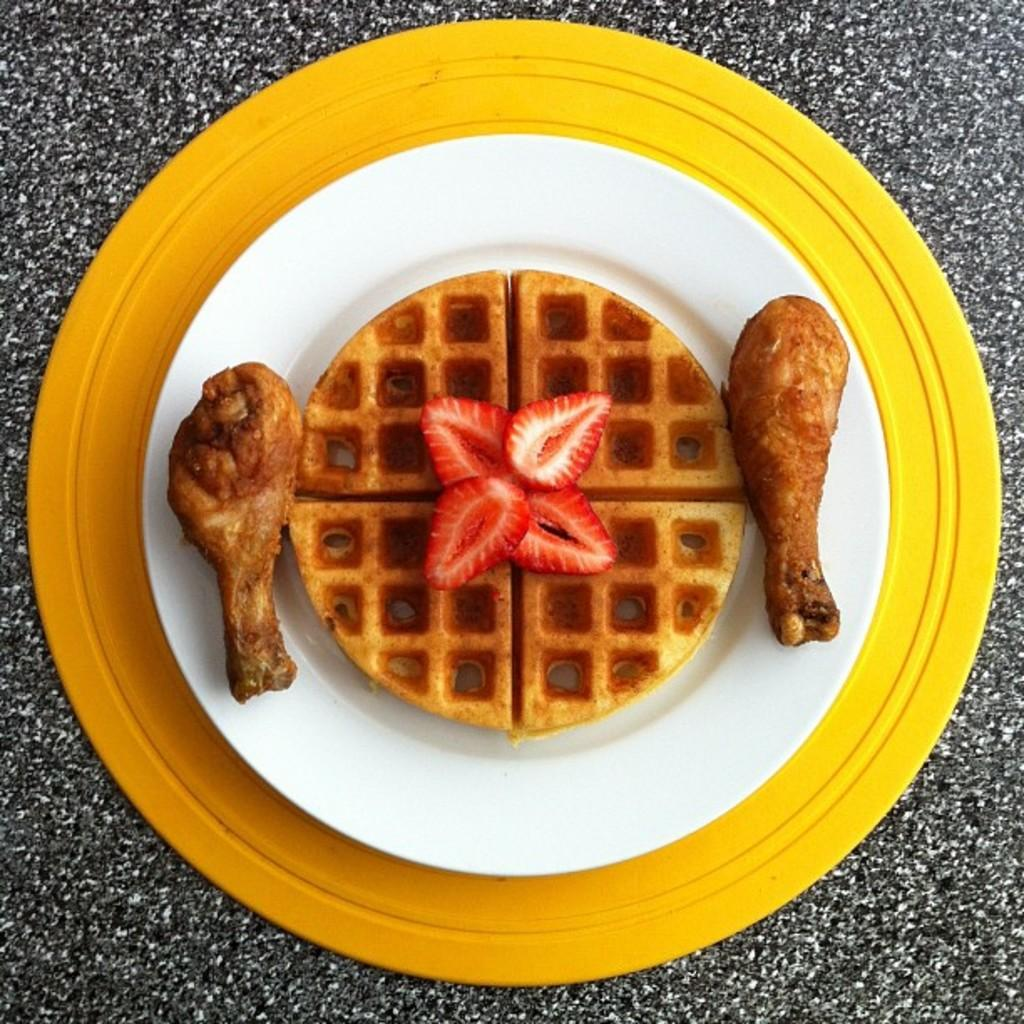What is on the plate that is visible in the image? There is a food item on a plate in the image. Where is the plate located in the image? The plate is placed on a surface in the image. What type of stream can be seen flowing through the food item in the image? There is no stream present in the image; it only features a food item on a plate placed on a surface. 